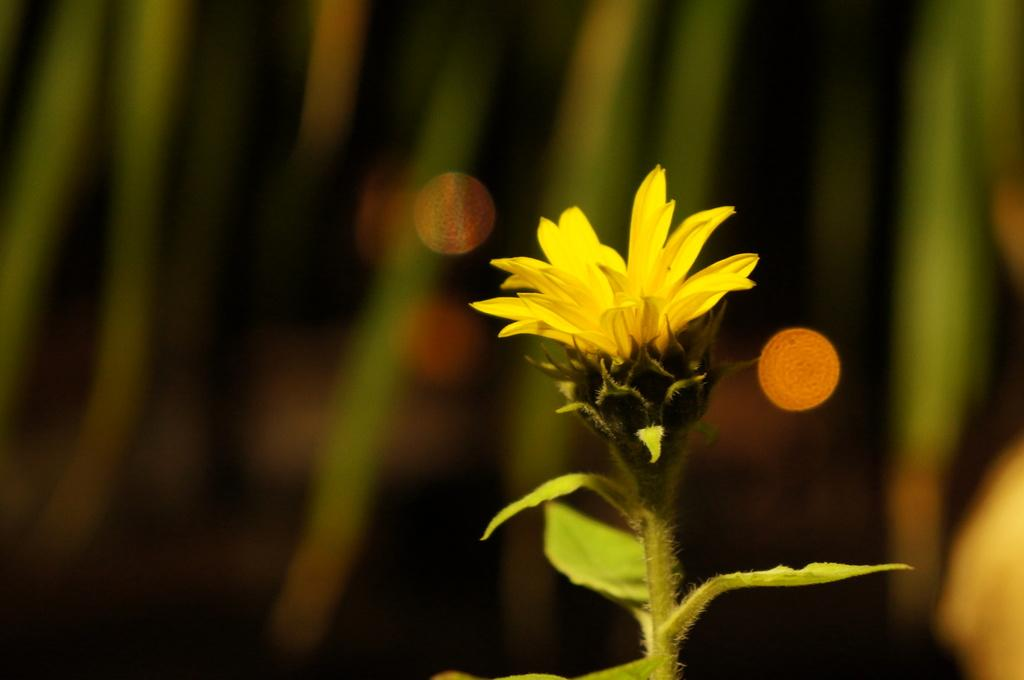What type of flower is in the image? There is a yellow flower in the image. What parts of the flower can be seen? The flower has a stem and leaves. What color is the background of the image? The background of the image is green. What additional details can be observed in the background? There are golden reddish dots in the background. How many tomatoes are hanging from the flower in the image? There are no tomatoes present in the image; it features a yellow flower with a stem and leaves. What type of nut is used as a badge in the image? There is no nut or badge present in the image. 